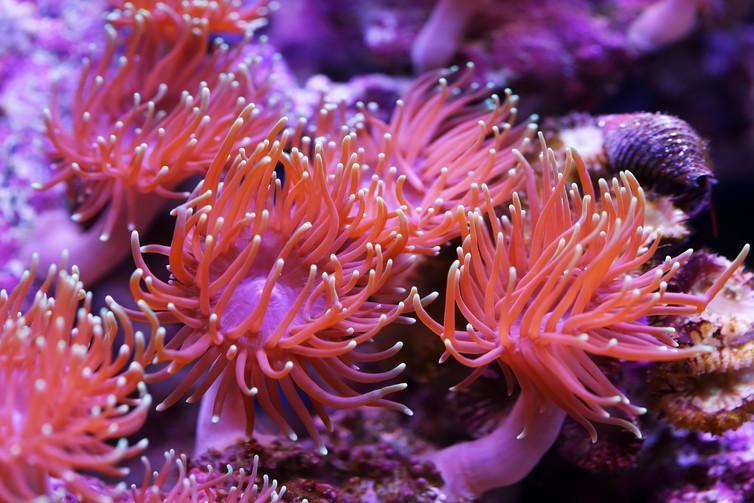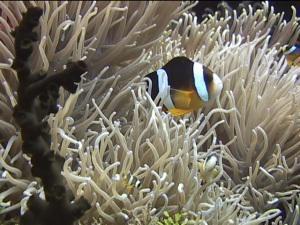The first image is the image on the left, the second image is the image on the right. For the images shown, is this caption "The creature in the image on the left has black and white markings." true? Answer yes or no. No. 